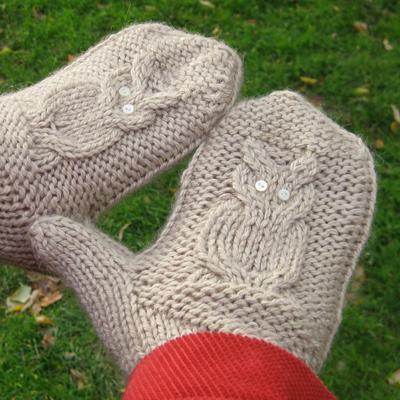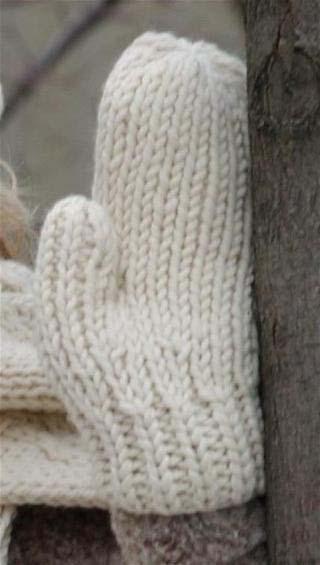The first image is the image on the left, the second image is the image on the right. Analyze the images presented: Is the assertion "One pair of mittons has a visible animal design knitted in, and the other pair does not." valid? Answer yes or no. Yes. The first image is the image on the left, the second image is the image on the right. Considering the images on both sides, is "A pair of gloves is worn by a human." valid? Answer yes or no. Yes. 